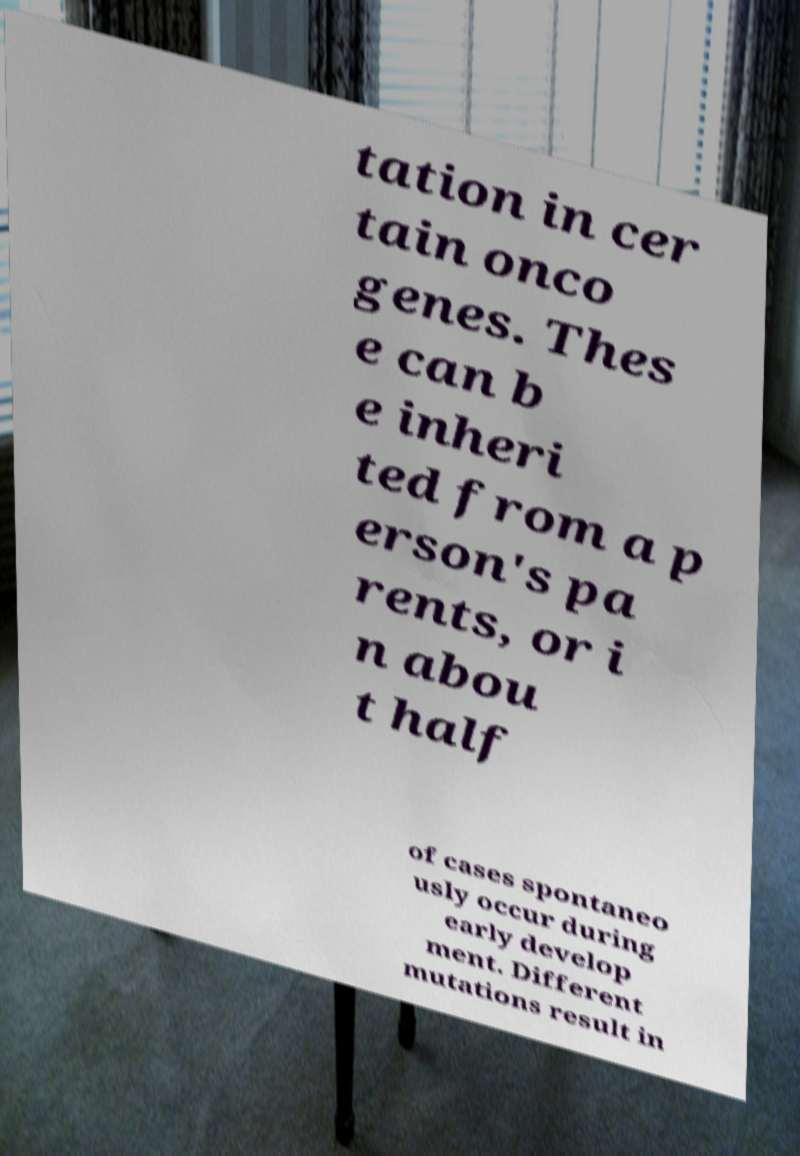There's text embedded in this image that I need extracted. Can you transcribe it verbatim? tation in cer tain onco genes. Thes e can b e inheri ted from a p erson's pa rents, or i n abou t half of cases spontaneo usly occur during early develop ment. Different mutations result in 